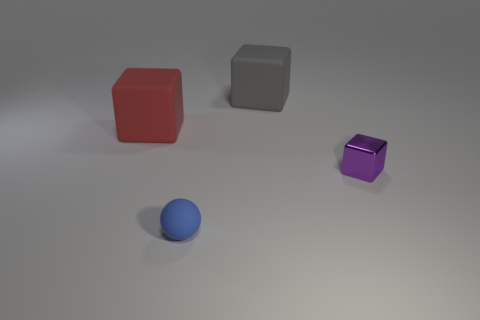Could you describe the lighting and shadows in the image? The lighting in the image is soft and diffused, creating gentle shadows that extend away from the objects. Based on the shadow positions, the light source is likely situated above and slightly to the right of the scene. The shadows help to give the objects a sense of weight and placement within the three-dimensional space. Do the shadows provide information about the texture of the surface? Yes, the smoothness of the shadows suggests that the surface is relatively flat and even. There are no harsh lines or distortions in the shadows that would indicate a textured or irregular surface. This smooth backdrop emphasizes the geometry and colors of the objects in the scene. 